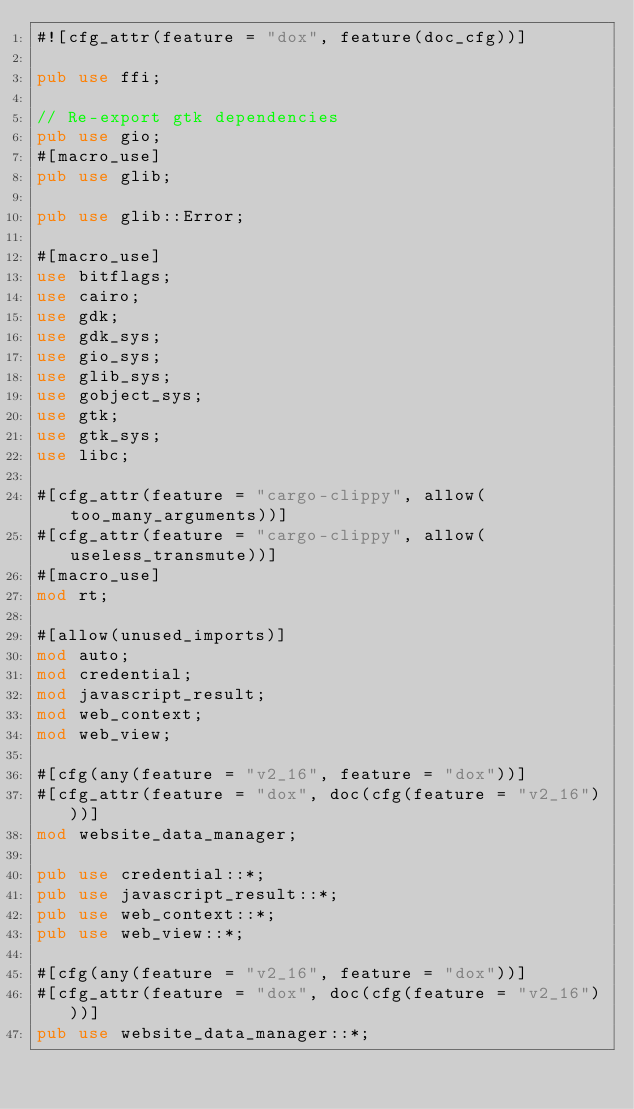<code> <loc_0><loc_0><loc_500><loc_500><_Rust_>#![cfg_attr(feature = "dox", feature(doc_cfg))]

pub use ffi;

// Re-export gtk dependencies
pub use gio;
#[macro_use]
pub use glib;

pub use glib::Error;

#[macro_use]
use bitflags;
use cairo;
use gdk;
use gdk_sys;
use gio_sys;
use glib_sys;
use gobject_sys;
use gtk;
use gtk_sys;
use libc;

#[cfg_attr(feature = "cargo-clippy", allow(too_many_arguments))]
#[cfg_attr(feature = "cargo-clippy", allow(useless_transmute))]
#[macro_use]
mod rt;

#[allow(unused_imports)]
mod auto;
mod credential;
mod javascript_result;
mod web_context;
mod web_view;

#[cfg(any(feature = "v2_16", feature = "dox"))]
#[cfg_attr(feature = "dox", doc(cfg(feature = "v2_16")))]
mod website_data_manager;

pub use credential::*;
pub use javascript_result::*;
pub use web_context::*;
pub use web_view::*;

#[cfg(any(feature = "v2_16", feature = "dox"))]
#[cfg_attr(feature = "dox", doc(cfg(feature = "v2_16")))]
pub use website_data_manager::*;
</code> 